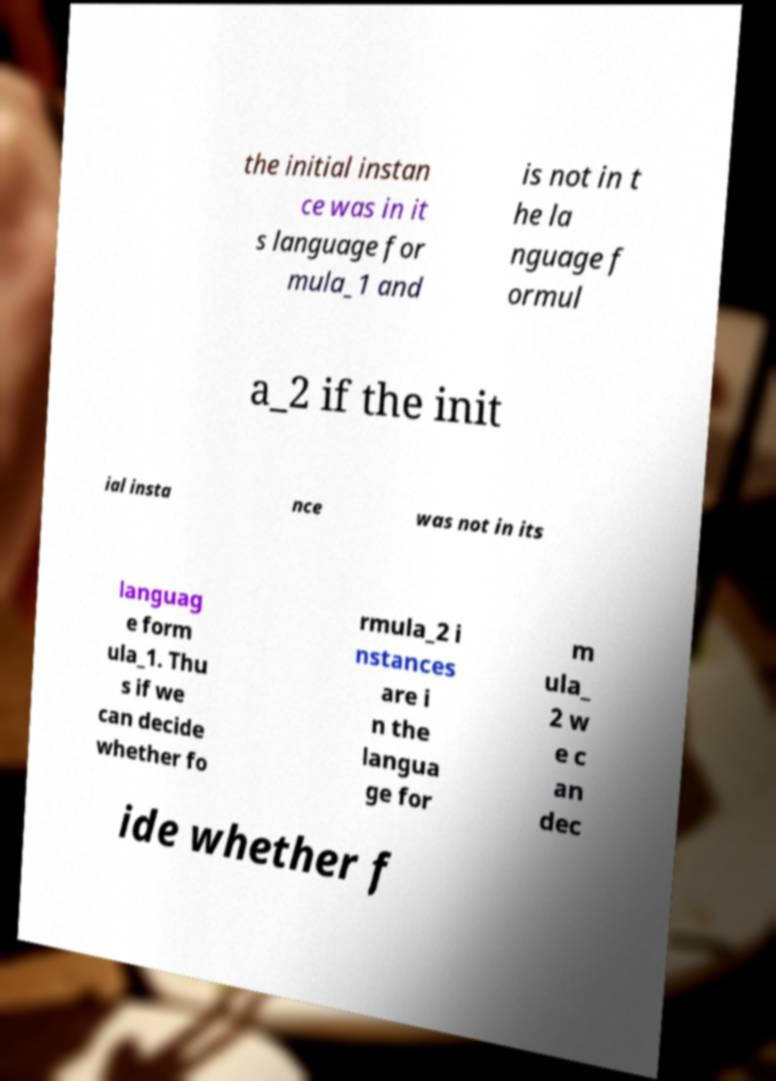Can you accurately transcribe the text from the provided image for me? the initial instan ce was in it s language for mula_1 and is not in t he la nguage f ormul a_2 if the init ial insta nce was not in its languag e form ula_1. Thu s if we can decide whether fo rmula_2 i nstances are i n the langua ge for m ula_ 2 w e c an dec ide whether f 